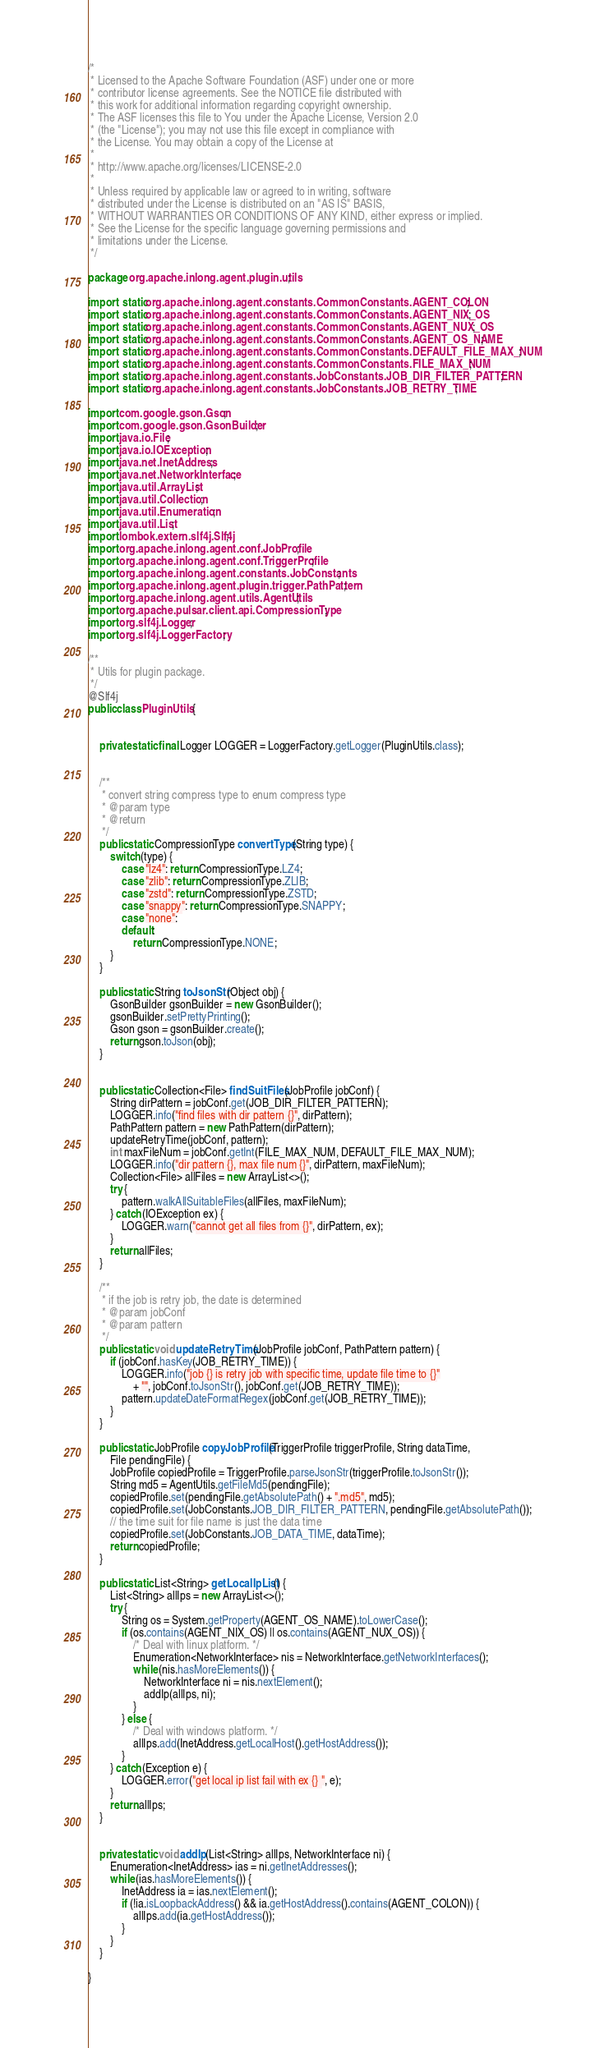<code> <loc_0><loc_0><loc_500><loc_500><_Java_>/*
 * Licensed to the Apache Software Foundation (ASF) under one or more
 * contributor license agreements. See the NOTICE file distributed with
 * this work for additional information regarding copyright ownership.
 * The ASF licenses this file to You under the Apache License, Version 2.0
 * (the "License"); you may not use this file except in compliance with
 * the License. You may obtain a copy of the License at
 *
 * http://www.apache.org/licenses/LICENSE-2.0
 *
 * Unless required by applicable law or agreed to in writing, software
 * distributed under the License is distributed on an "AS IS" BASIS,
 * WITHOUT WARRANTIES OR CONDITIONS OF ANY KIND, either express or implied.
 * See the License for the specific language governing permissions and
 * limitations under the License.
 */

package org.apache.inlong.agent.plugin.utils;

import static org.apache.inlong.agent.constants.CommonConstants.AGENT_COLON;
import static org.apache.inlong.agent.constants.CommonConstants.AGENT_NIX_OS;
import static org.apache.inlong.agent.constants.CommonConstants.AGENT_NUX_OS;
import static org.apache.inlong.agent.constants.CommonConstants.AGENT_OS_NAME;
import static org.apache.inlong.agent.constants.CommonConstants.DEFAULT_FILE_MAX_NUM;
import static org.apache.inlong.agent.constants.CommonConstants.FILE_MAX_NUM;
import static org.apache.inlong.agent.constants.JobConstants.JOB_DIR_FILTER_PATTERN;
import static org.apache.inlong.agent.constants.JobConstants.JOB_RETRY_TIME;

import com.google.gson.Gson;
import com.google.gson.GsonBuilder;
import java.io.File;
import java.io.IOException;
import java.net.InetAddress;
import java.net.NetworkInterface;
import java.util.ArrayList;
import java.util.Collection;
import java.util.Enumeration;
import java.util.List;
import lombok.extern.slf4j.Slf4j;
import org.apache.inlong.agent.conf.JobProfile;
import org.apache.inlong.agent.conf.TriggerProfile;
import org.apache.inlong.agent.constants.JobConstants;
import org.apache.inlong.agent.plugin.trigger.PathPattern;
import org.apache.inlong.agent.utils.AgentUtils;
import org.apache.pulsar.client.api.CompressionType;
import org.slf4j.Logger;
import org.slf4j.LoggerFactory;

/**
 * Utils for plugin package.
 */
@Slf4j
public class PluginUtils {


    private static final Logger LOGGER = LoggerFactory.getLogger(PluginUtils.class);


    /**
     * convert string compress type to enum compress type
     * @param type
     * @return
     */
    public static CompressionType convertType(String type) {
        switch (type) {
            case "lz4": return CompressionType.LZ4;
            case "zlib": return CompressionType.ZLIB;
            case "zstd": return CompressionType.ZSTD;
            case "snappy": return CompressionType.SNAPPY;
            case "none":
            default:
                return CompressionType.NONE;
        }
    }

    public static String toJsonStr(Object obj) {
        GsonBuilder gsonBuilder = new GsonBuilder();
        gsonBuilder.setPrettyPrinting();
        Gson gson = gsonBuilder.create();
        return gson.toJson(obj);
    }


    public static Collection<File> findSuitFiles(JobProfile jobConf) {
        String dirPattern = jobConf.get(JOB_DIR_FILTER_PATTERN);
        LOGGER.info("find files with dir pattern {}", dirPattern);
        PathPattern pattern = new PathPattern(dirPattern);
        updateRetryTime(jobConf, pattern);
        int maxFileNum = jobConf.getInt(FILE_MAX_NUM, DEFAULT_FILE_MAX_NUM);
        LOGGER.info("dir pattern {}, max file num {}", dirPattern, maxFileNum);
        Collection<File> allFiles = new ArrayList<>();
        try {
            pattern.walkAllSuitableFiles(allFiles, maxFileNum);
        } catch (IOException ex) {
            LOGGER.warn("cannot get all files from {}", dirPattern, ex);
        }
        return allFiles;
    }

    /**
     * if the job is retry job, the date is determined
     * @param jobConf
     * @param pattern
     */
    public static void updateRetryTime(JobProfile jobConf, PathPattern pattern) {
        if (jobConf.hasKey(JOB_RETRY_TIME)) {
            LOGGER.info("job {} is retry job with specific time, update file time to {}"
                + "", jobConf.toJsonStr(), jobConf.get(JOB_RETRY_TIME));
            pattern.updateDateFormatRegex(jobConf.get(JOB_RETRY_TIME));
        }
    }

    public static JobProfile copyJobProfile(TriggerProfile triggerProfile, String dataTime,
        File pendingFile) {
        JobProfile copiedProfile = TriggerProfile.parseJsonStr(triggerProfile.toJsonStr());
        String md5 = AgentUtils.getFileMd5(pendingFile);
        copiedProfile.set(pendingFile.getAbsolutePath() + ".md5", md5);
        copiedProfile.set(JobConstants.JOB_DIR_FILTER_PATTERN, pendingFile.getAbsolutePath());
        // the time suit for file name is just the data time
        copiedProfile.set(JobConstants.JOB_DATA_TIME, dataTime);
        return copiedProfile;
    }

    public static List<String> getLocalIpList() {
        List<String> allIps = new ArrayList<>();
        try {
            String os = System.getProperty(AGENT_OS_NAME).toLowerCase();
            if (os.contains(AGENT_NIX_OS) || os.contains(AGENT_NUX_OS)) {
                /* Deal with linux platform. */
                Enumeration<NetworkInterface> nis = NetworkInterface.getNetworkInterfaces();
                while (nis.hasMoreElements()) {
                    NetworkInterface ni = nis.nextElement();
                    addIp(allIps, ni);
                }
            } else {
                /* Deal with windows platform. */
                allIps.add(InetAddress.getLocalHost().getHostAddress());
            }
        } catch (Exception e) {
            LOGGER.error("get local ip list fail with ex {} ", e);
        }
        return allIps;
    }


    private static void addIp(List<String> allIps, NetworkInterface ni) {
        Enumeration<InetAddress> ias = ni.getInetAddresses();
        while (ias.hasMoreElements()) {
            InetAddress ia = ias.nextElement();
            if (!ia.isLoopbackAddress() && ia.getHostAddress().contains(AGENT_COLON)) {
                allIps.add(ia.getHostAddress());
            }
        }
    }

}
</code> 